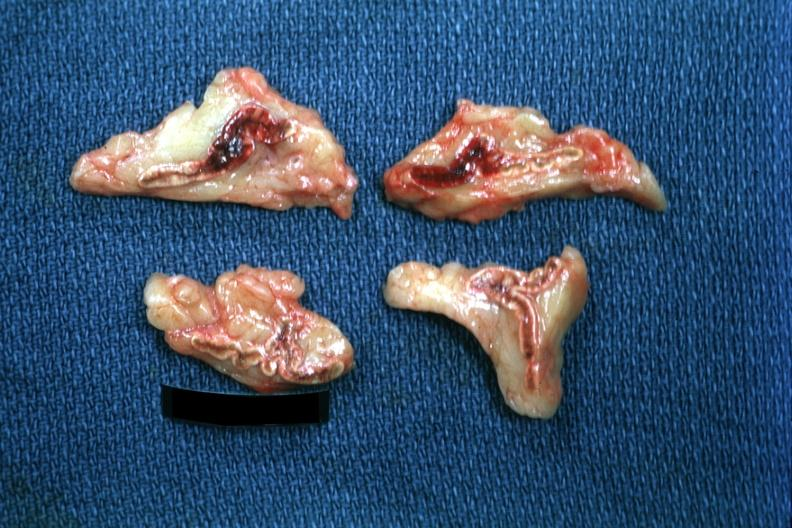s angiogram present?
Answer the question using a single word or phrase. No 